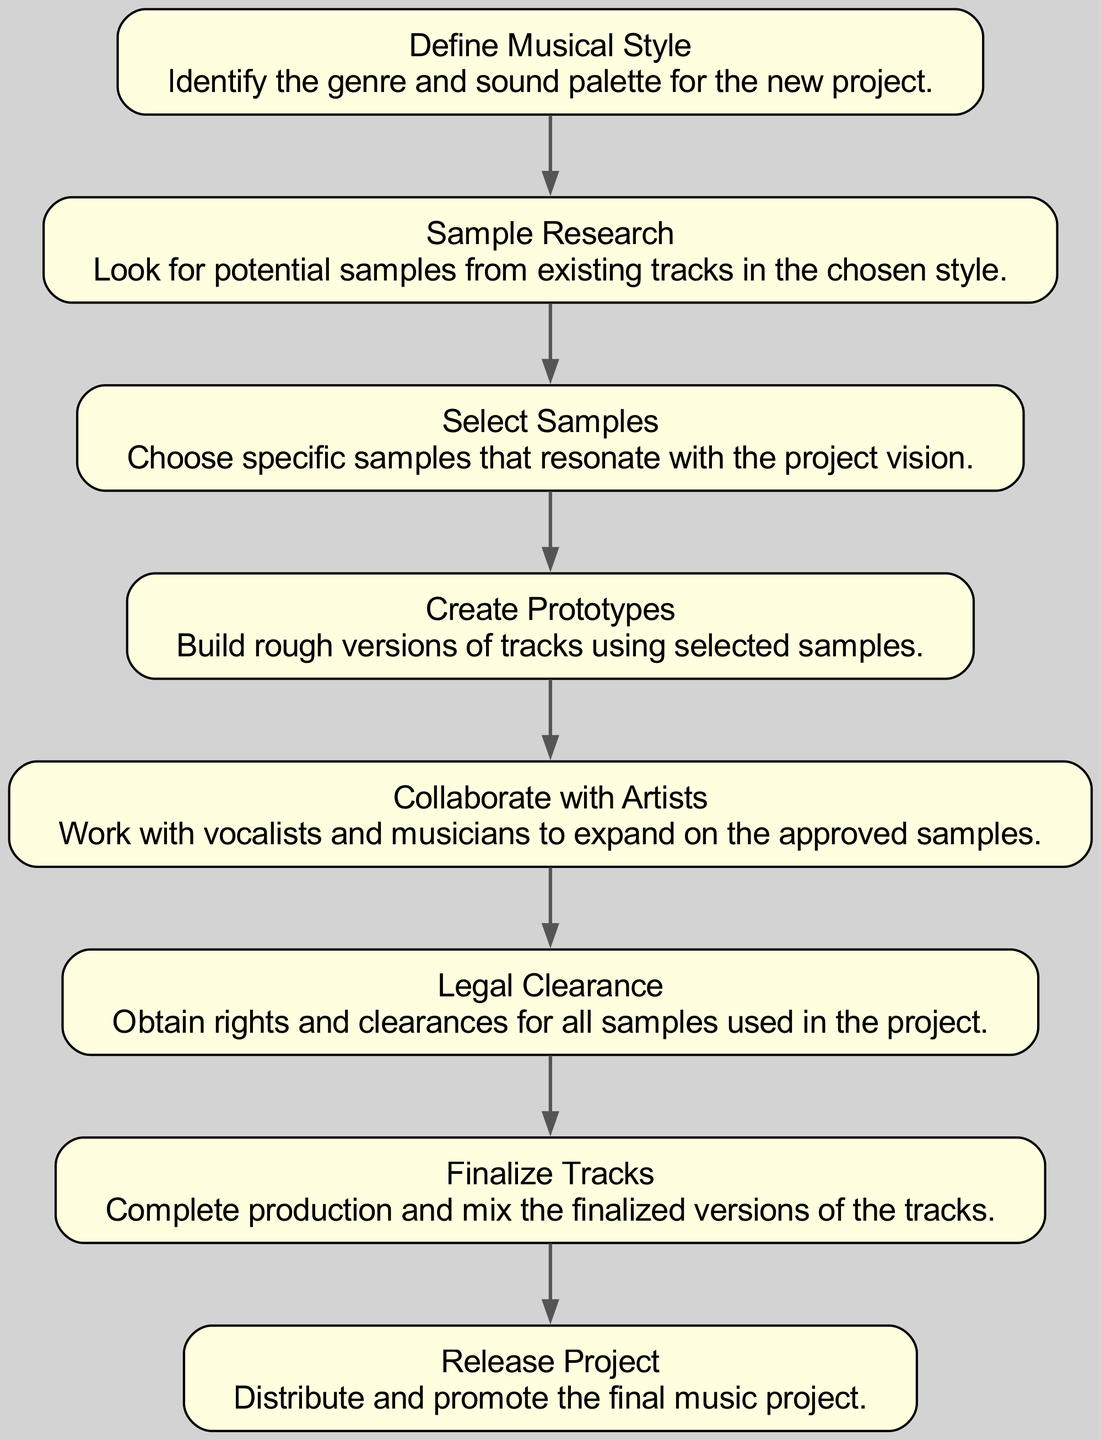What is the first step in the workflow? The first step in the workflow is defined as "Define Musical Style," which indicates the initial task of identifying the genre and sound palette for the project.
Answer: Define Musical Style How many nodes are in the diagram? Counting each of the unique steps represented in the diagram, there are eight nodes, which include all the defined phases of the workflow.
Answer: 8 What task follows "Sample Research"? After "Sample Research," the next task is "Select Samples," indicating the transition from gathering information to making selections based on the research.
Answer: Select Samples Which step is directly before "Legal Clearance"? The step directly before "Legal Clearance" is "Collaborate with Artists," showing that artist collaboration happens prior to obtaining legal rights for samples.
Answer: Collaborate with Artists Is "Finalize Tracks" the last step in the workflow? Yes, "Finalize Tracks" is indeed the second to last step, with "Release Project" being the final step, indicating that finalizing occurs just before the release.
Answer: No What type of transition connects "Create Prototypes" to "Collaborate with Artists"? The transition from "Create Prototypes" to "Collaborate with Artists" is a directed edge, which represents a progression in the workflow from producing rough tracks to collaboration with other artists.
Answer: Directed edge How many edges are in the diagram? There are seven edges in total, as each connection from one step to the subsequent step represents one edge in the directed graph structure.
Answer: 7 Which two steps connect directly to "Release Project"? The only step that connects directly to "Release Project" is "Finalize Tracks," indicating that the finalization is the last process before releasing the project.
Answer: Finalize Tracks 